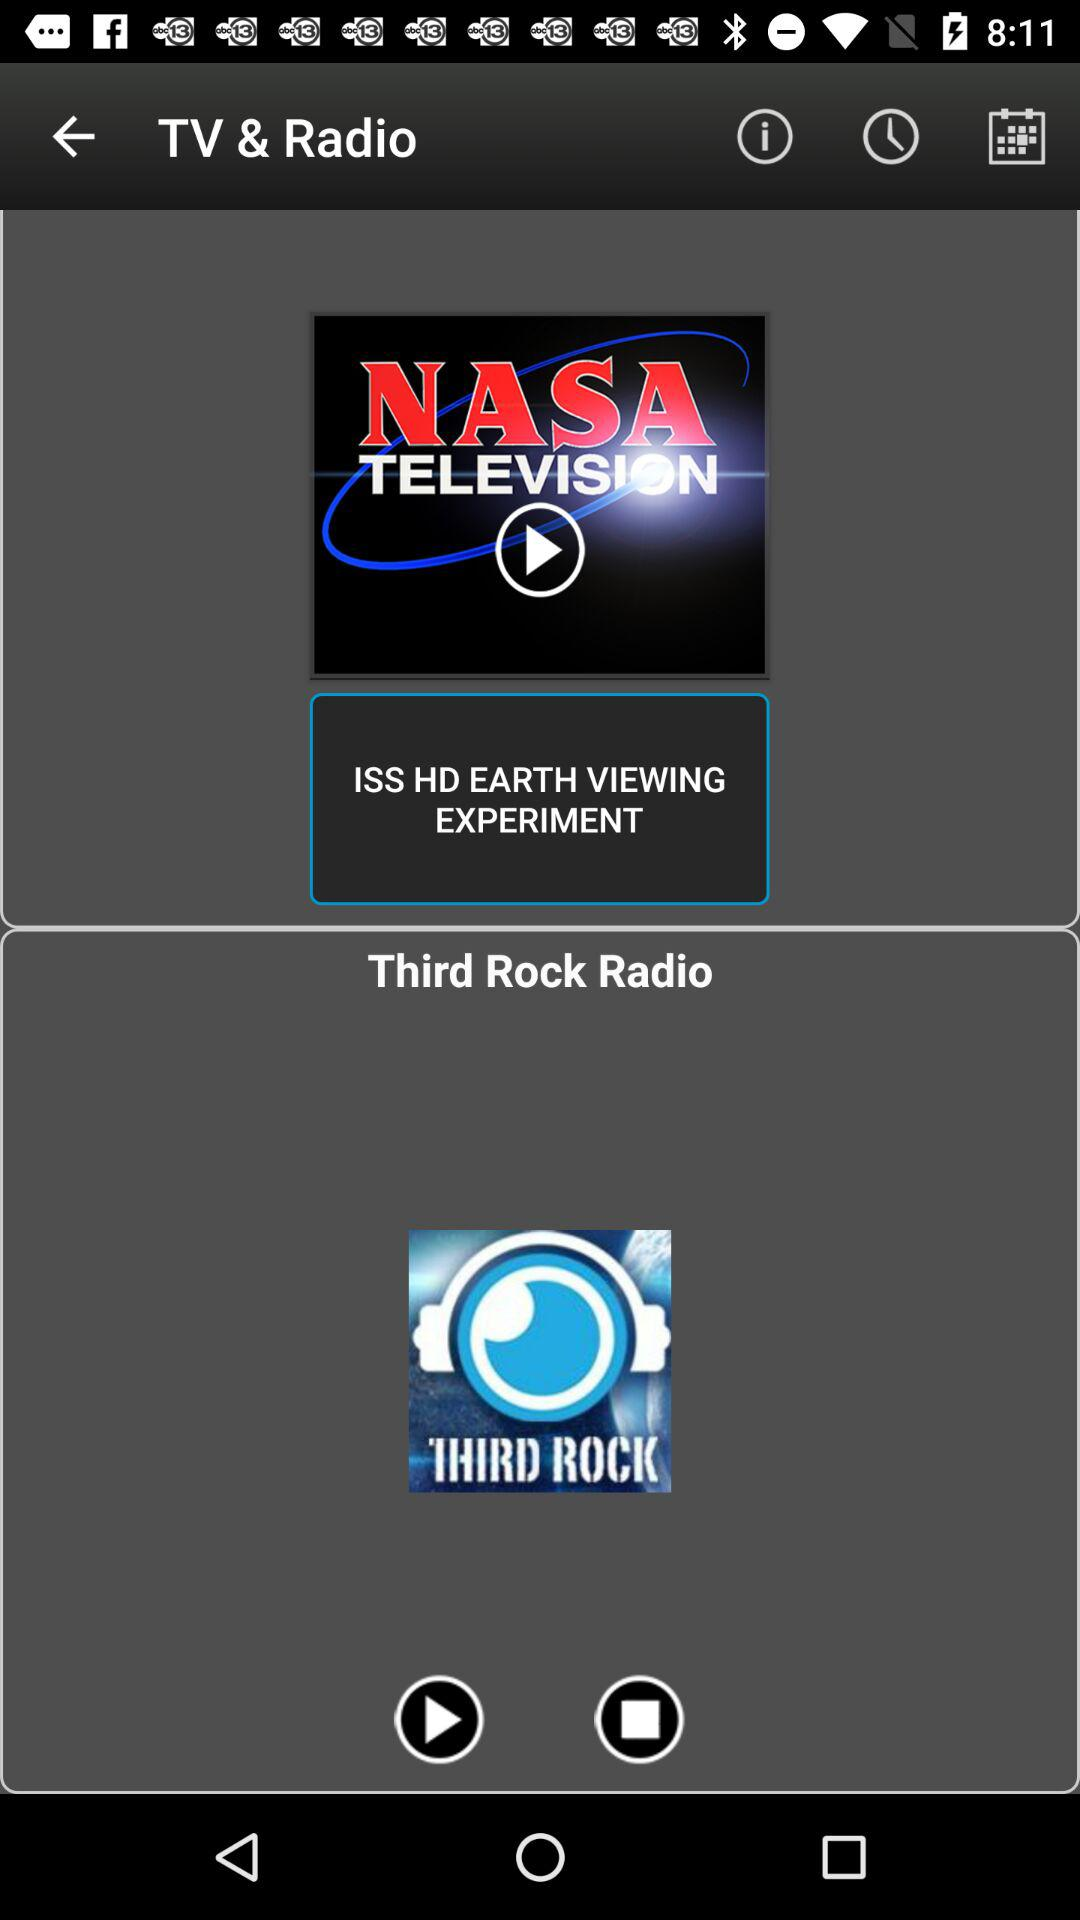What is the application name? The application name is "TV & Radio". 